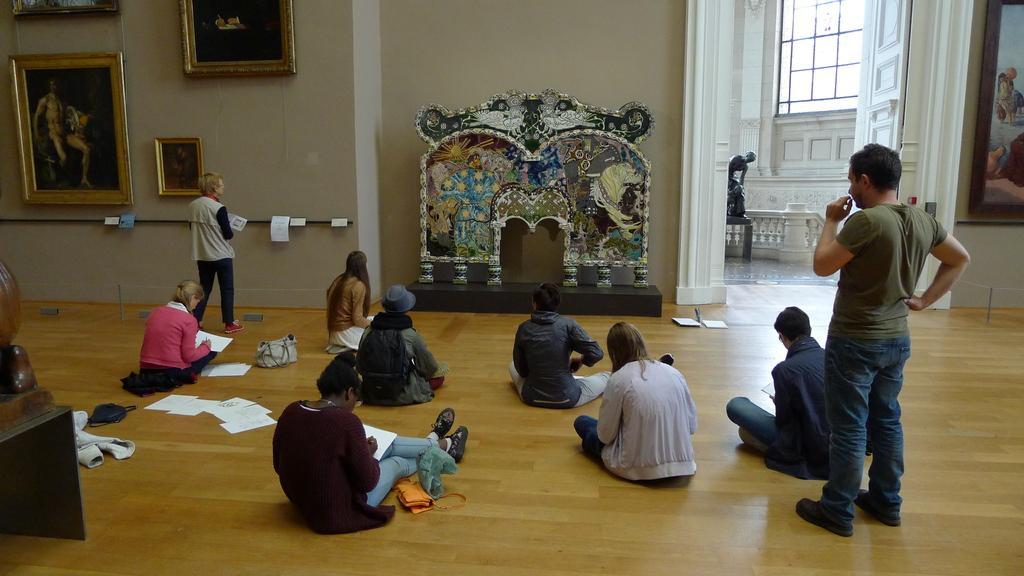In one or two sentences, can you explain what this image depicts? In this picture I can see that there are some people sitting on the floor and they have papers with them. There are two persons standing and here there is a wall and there are photo frames on the wall and on the right side there is a door. 